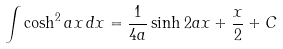Convert formula to latex. <formula><loc_0><loc_0><loc_500><loc_500>\int \cosh ^ { 2 } a x \, d x = { \frac { 1 } { 4 a } } \sinh 2 a x + { \frac { x } { 2 } } + C</formula> 